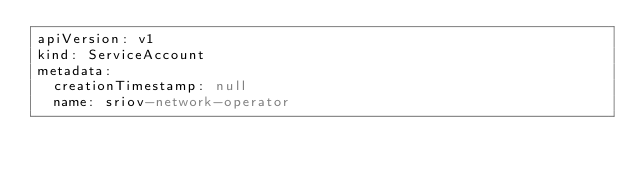Convert code to text. <code><loc_0><loc_0><loc_500><loc_500><_YAML_>apiVersion: v1
kind: ServiceAccount
metadata:
  creationTimestamp: null
  name: sriov-network-operator
</code> 